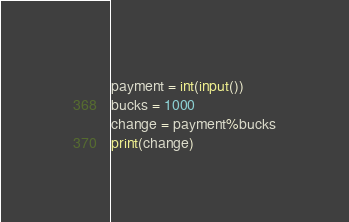Convert code to text. <code><loc_0><loc_0><loc_500><loc_500><_Python_>payment = int(input())
bucks = 1000
change = payment%bucks
print(change)</code> 